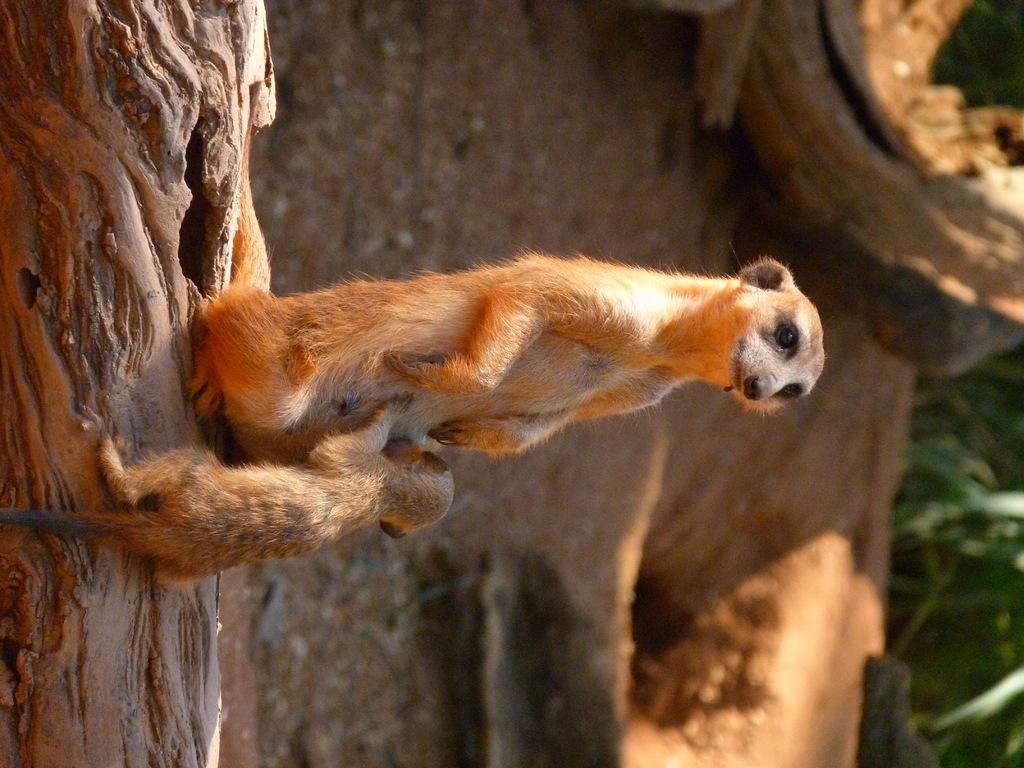What are the animals sitting on in the image? The animals are on a trunk in the image. What can be seen behind the animals? The ground is visible behind the animals. What type of vegetation is present in the image? There are plants in the image. What is located on the right side of the image? There is a wooden object on the right side of the image. What type of industry can be seen in the background of the image? There is no industry visible in the image; it features animals on a trunk, plants, and a wooden object. Can you tell me how many beetles are crawling on the trunk in the image? There is no beetle present in the image; it features animals other than beetles. 